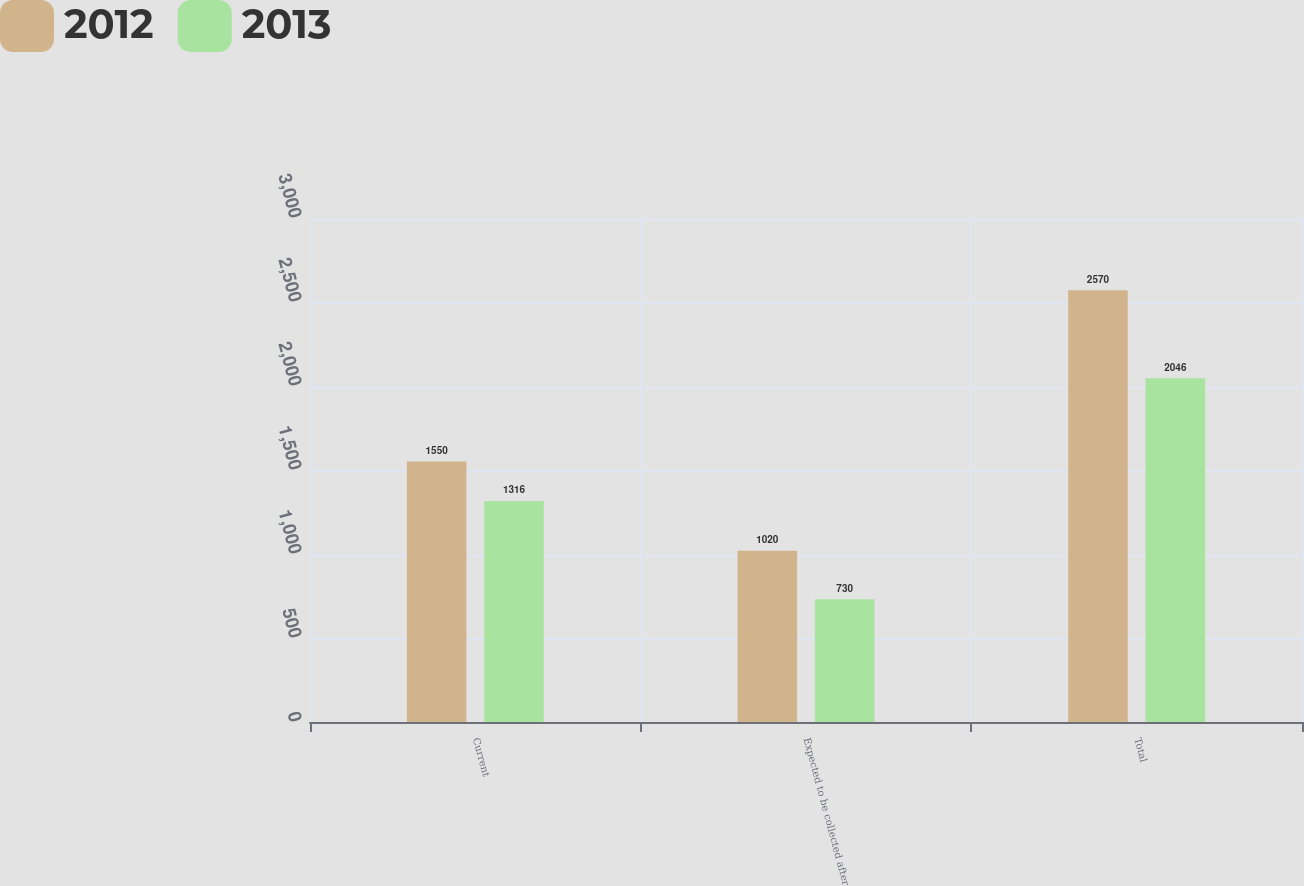<chart> <loc_0><loc_0><loc_500><loc_500><stacked_bar_chart><ecel><fcel>Current<fcel>Expected to be collected after<fcel>Total<nl><fcel>2012<fcel>1550<fcel>1020<fcel>2570<nl><fcel>2013<fcel>1316<fcel>730<fcel>2046<nl></chart> 